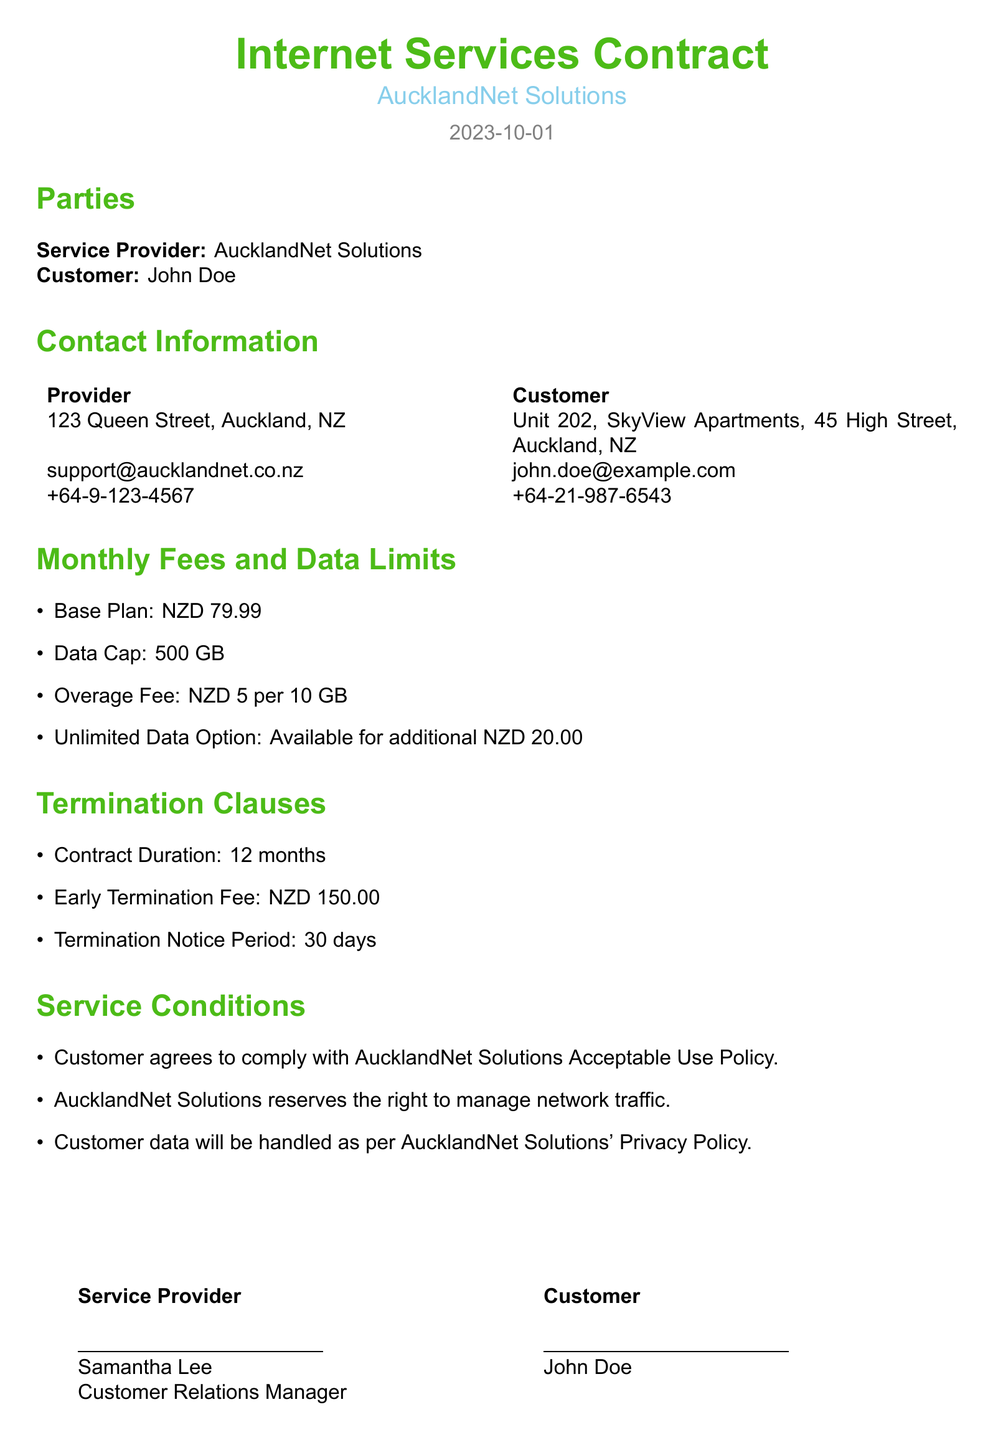What is the name of the service provider? The document states that the service provider is "AucklandNet Solutions."
Answer: AucklandNet Solutions What is the monthly fee for the base plan? The document lists the monthly fee for the base plan as NZD 79.99.
Answer: NZD 79.99 What is the data cap for the plan? According to the document, the data cap is 500 GB.
Answer: 500 GB What is the fee for exceeding the data cap? The document mentions an overage fee of NZD 5 per 10 GB of excess data.
Answer: NZD 5 per 10 GB What is the early termination fee? The document states an early termination fee of NZD 150.00.
Answer: NZD 150.00 How long is the contract duration? The document specifies that the contract duration is 12 months.
Answer: 12 months What is the termination notice period? The document indicates that the termination notice period is 30 days.
Answer: 30 days Is there an unlimited data option available? The document confirms that an unlimited data option is available for an additional fee.
Answer: Yes What must the customer agree to regarding usage? The document states that the customer agrees to comply with AucklandNet Solutions Acceptable Use Policy.
Answer: Acceptable Use Policy 